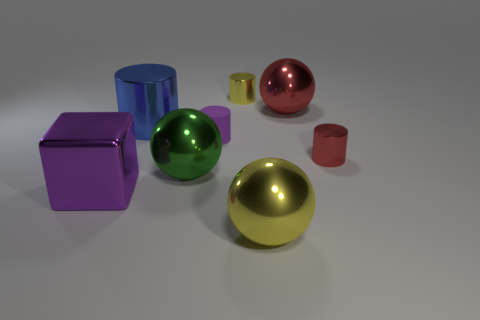Is the number of large blue objects right of the small purple matte object less than the number of large yellow metallic balls?
Your answer should be very brief. Yes. What color is the thing behind the big red ball?
Offer a very short reply. Yellow. There is a cylinder that is the same color as the big shiny block; what material is it?
Give a very brief answer. Rubber. Is there a blue rubber object that has the same shape as the big yellow object?
Make the answer very short. No. How many large blue metallic objects are the same shape as the large yellow metallic object?
Your answer should be compact. 0. Is the color of the block the same as the small rubber object?
Your answer should be compact. Yes. Is the number of blue shiny cylinders less than the number of brown metal cubes?
Make the answer very short. No. What is the large sphere to the left of the big yellow thing made of?
Keep it short and to the point. Metal. What is the material of the cylinder that is the same size as the red sphere?
Your response must be concise. Metal. The tiny cylinder left of the small metallic object that is left of the yellow metal thing in front of the tiny yellow cylinder is made of what material?
Your answer should be compact. Rubber. 